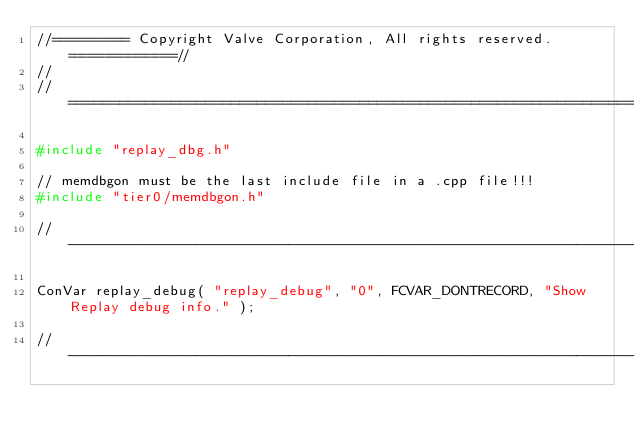Convert code to text. <code><loc_0><loc_0><loc_500><loc_500><_C++_>//========= Copyright Valve Corporation, All rights reserved. ============//
//
//=======================================================================================//

#include "replay_dbg.h"

// memdbgon must be the last include file in a .cpp file!!!
#include "tier0/memdbgon.h"

//----------------------------------------------------------------------------------------

ConVar replay_debug( "replay_debug", "0", FCVAR_DONTRECORD, "Show Replay debug info." );

//----------------------------------------------------------------------------------------</code> 